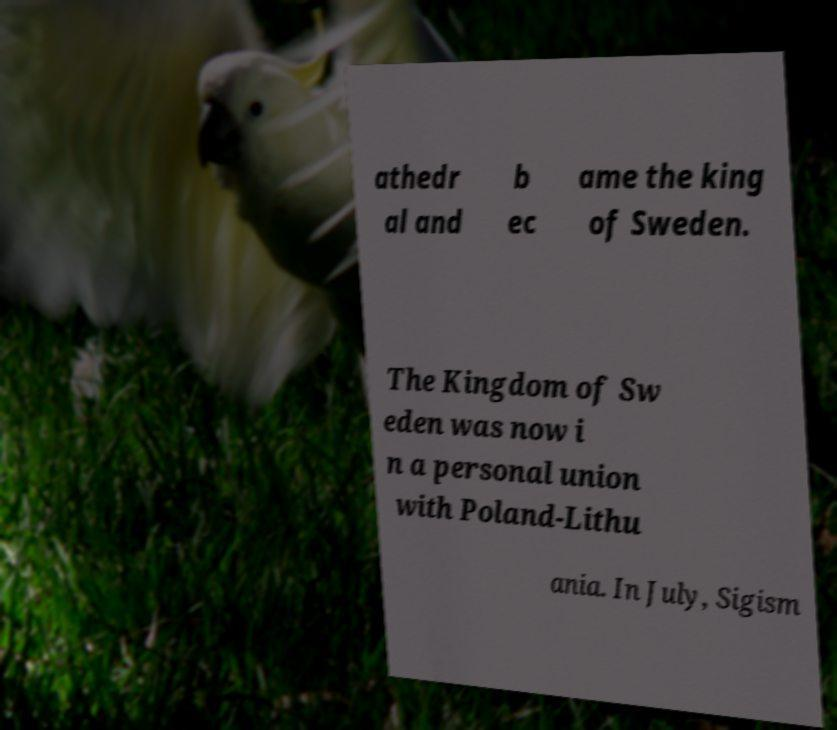What messages or text are displayed in this image? I need them in a readable, typed format. athedr al and b ec ame the king of Sweden. The Kingdom of Sw eden was now i n a personal union with Poland-Lithu ania. In July, Sigism 